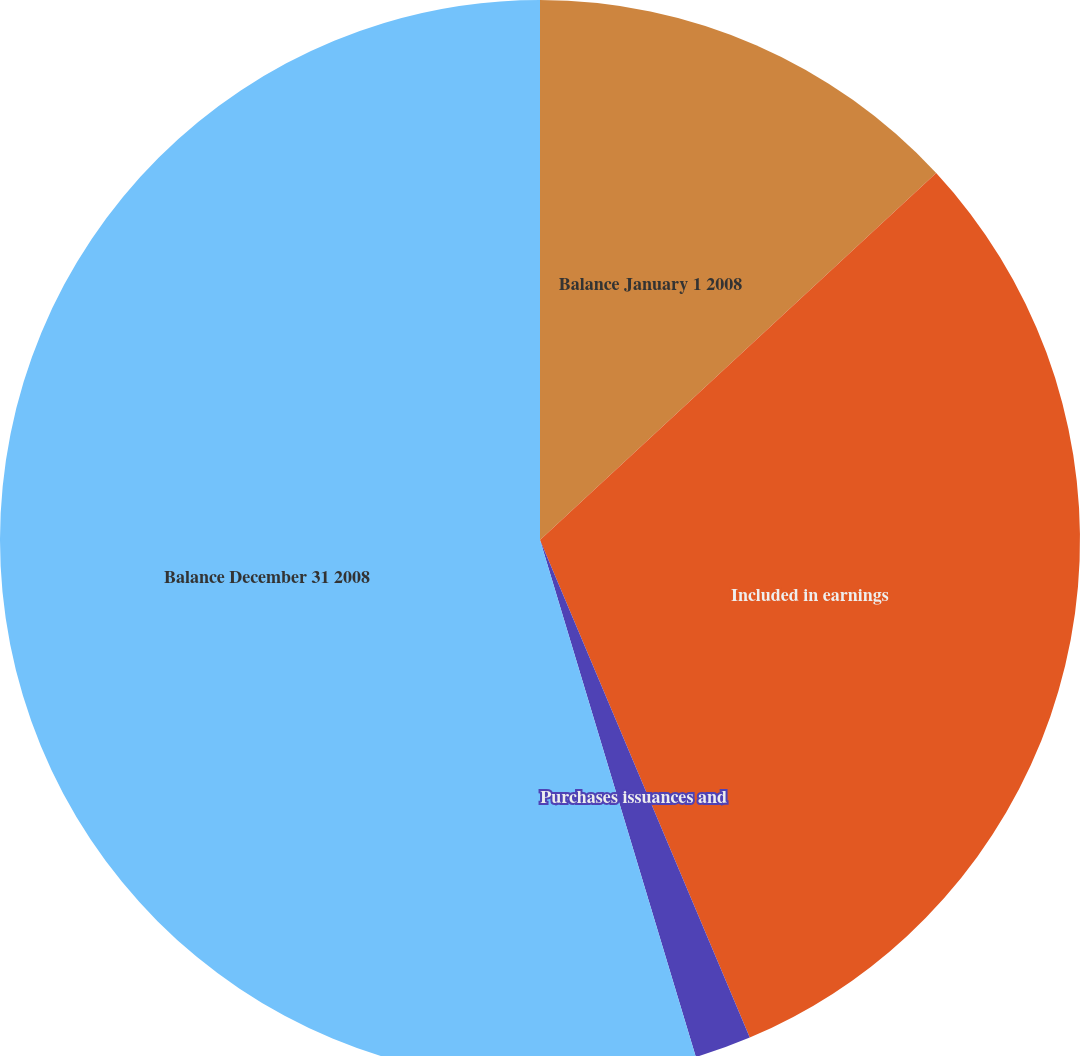Convert chart. <chart><loc_0><loc_0><loc_500><loc_500><pie_chart><fcel>Balance January 1 2008<fcel>Included in earnings<fcel>Purchases issuances and<fcel>Balance December 31 2008<nl><fcel>13.11%<fcel>30.54%<fcel>1.69%<fcel>54.66%<nl></chart> 